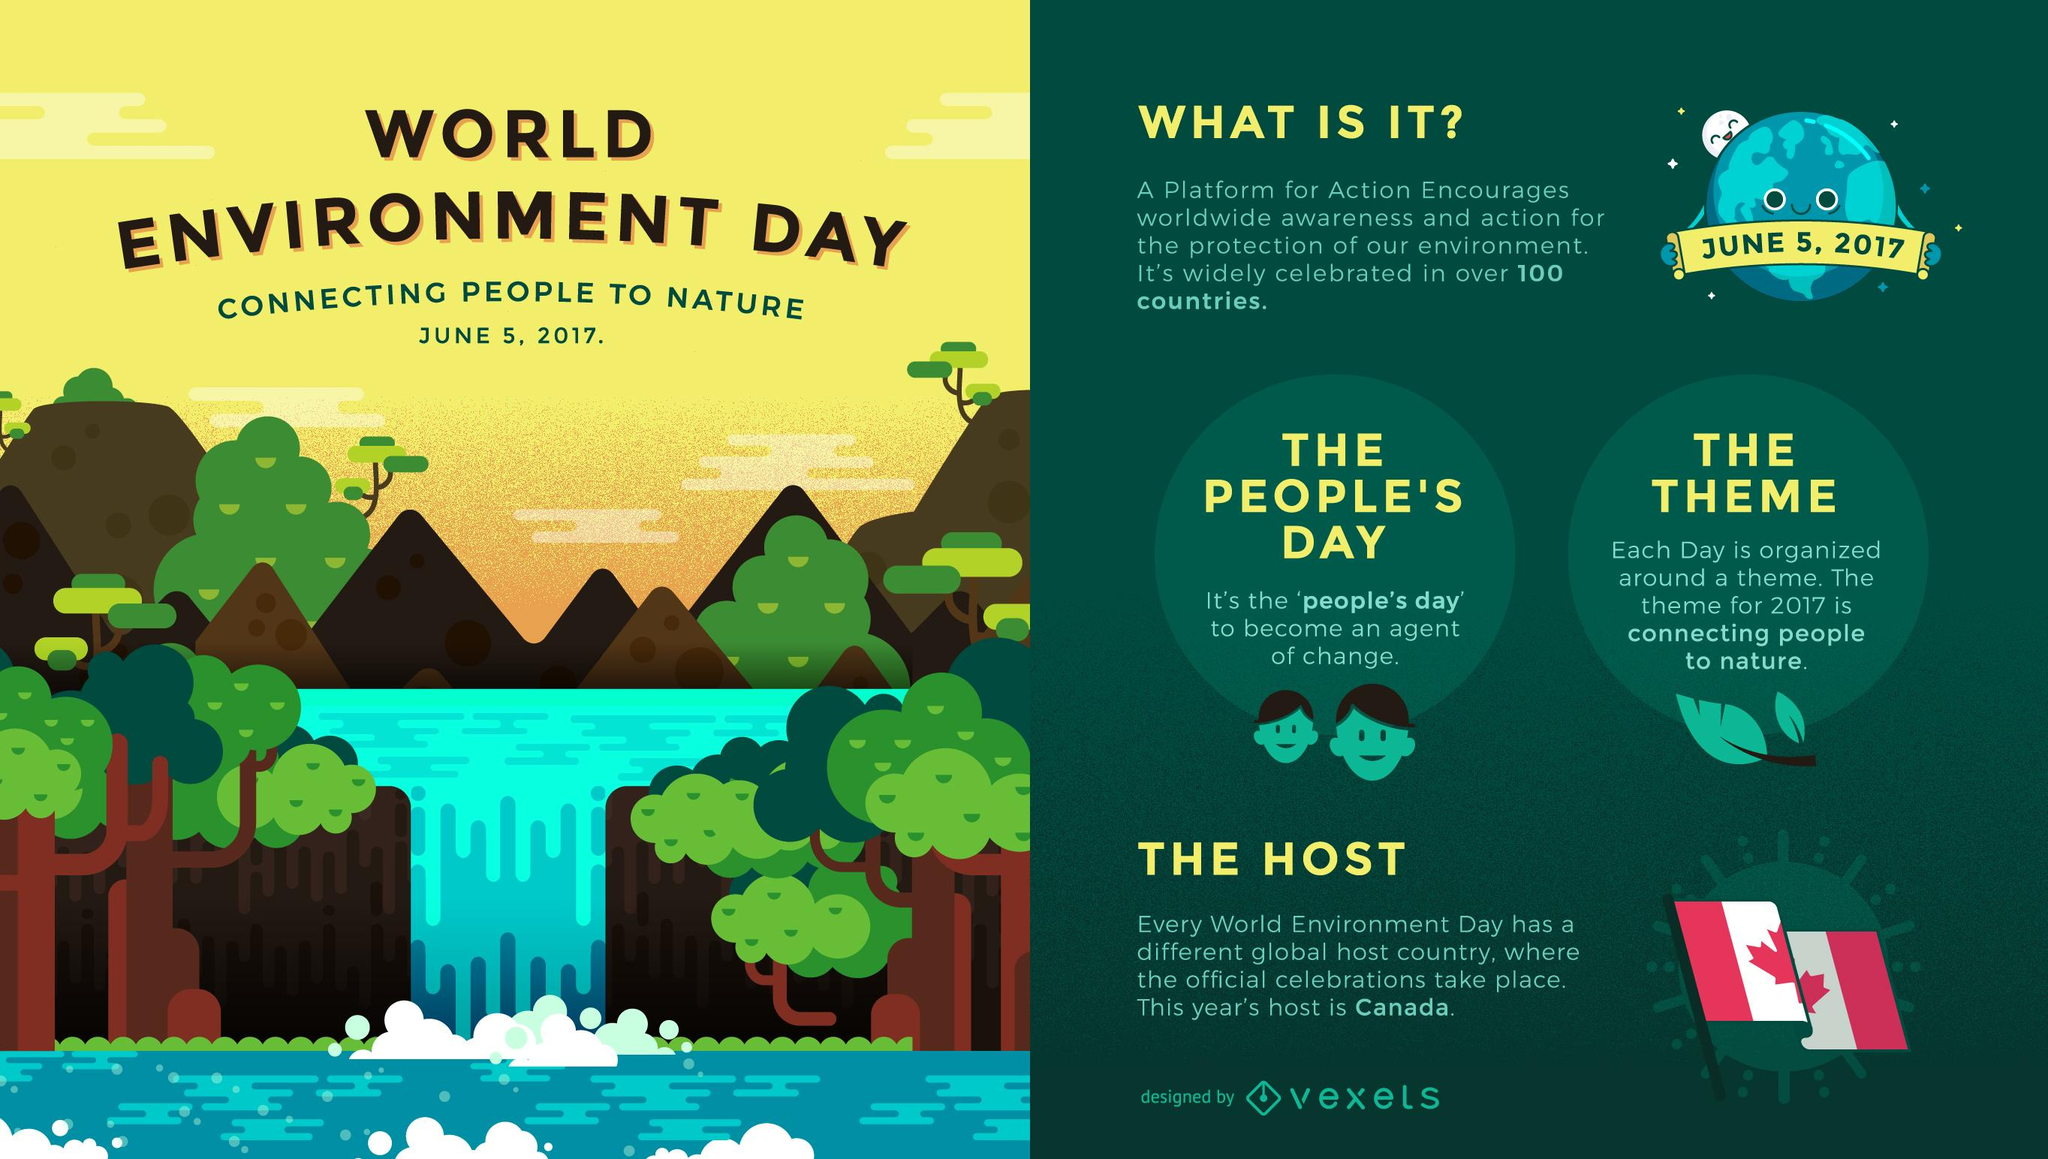Give some essential details in this illustration. The Main heading has 4 points under it. There is only one flag present in this infographic. 